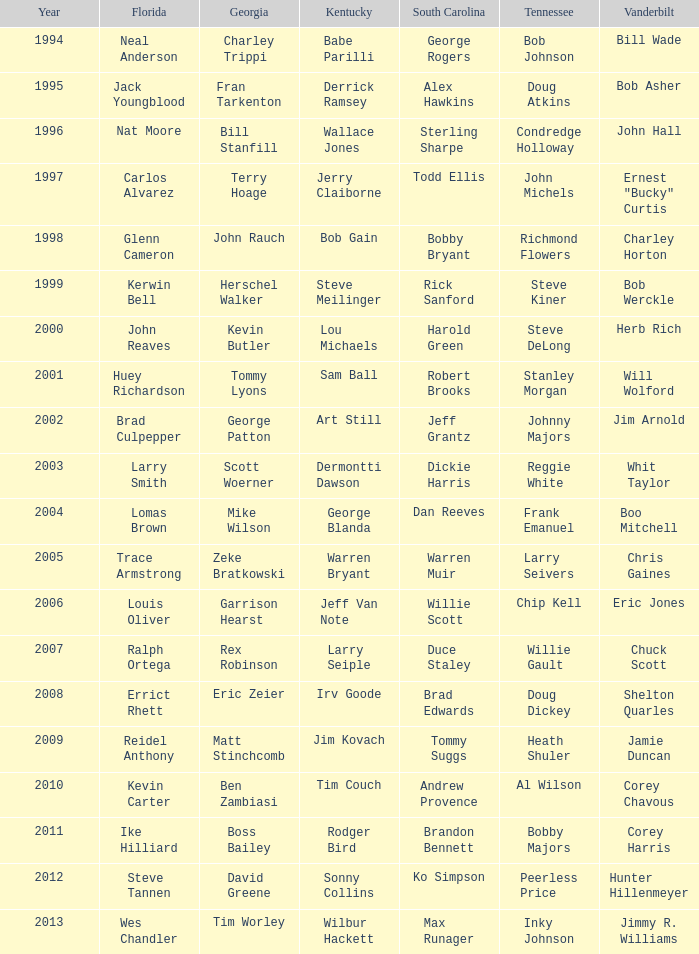What is the Tennessee with a Kentucky of Larry Seiple Willie Gault. 